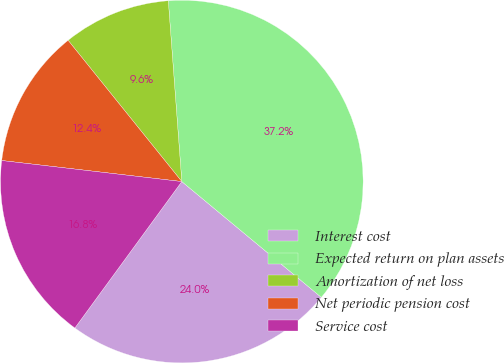Convert chart. <chart><loc_0><loc_0><loc_500><loc_500><pie_chart><fcel>Interest cost<fcel>Expected return on plan assets<fcel>Amortization of net loss<fcel>Net periodic pension cost<fcel>Service cost<nl><fcel>24.01%<fcel>37.21%<fcel>9.6%<fcel>12.36%<fcel>16.81%<nl></chart> 